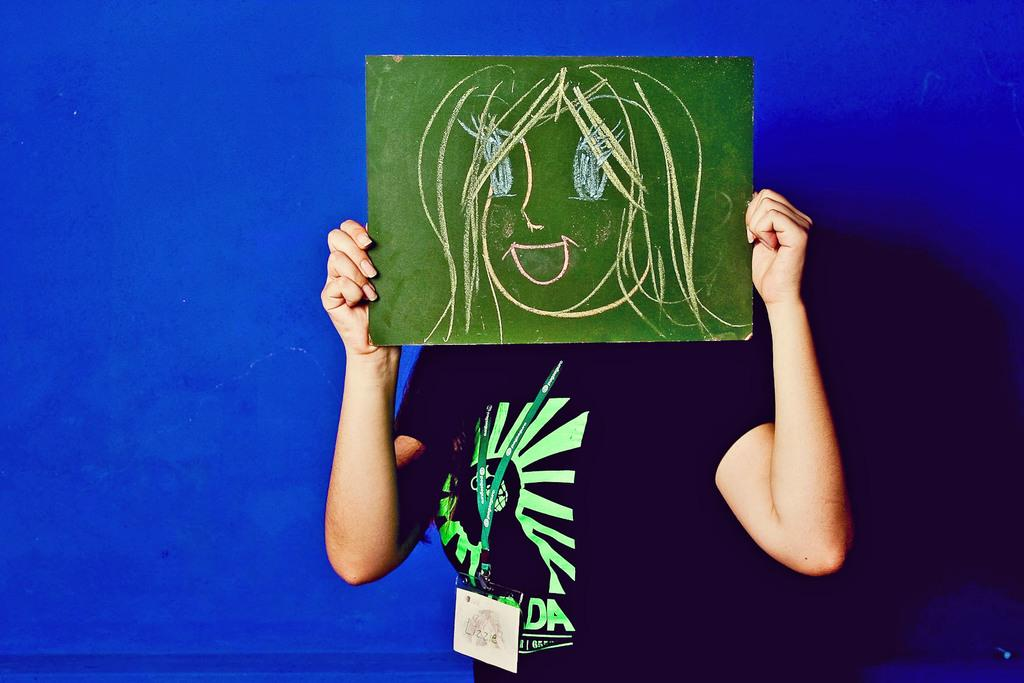Who or what is present in the image? There is a person in the image. What can be seen in the background of the image? The background of the image is blue. What is the person wearing? The person is wearing clothes. What is the person doing with the board? The person is covering their face with a board. What is depicted on the board? The board contains a drawing. What type of meat can be seen hanging from the person's clothes in the image? There is no meat present in the image; the person is wearing clothes and covering their face with a board. 